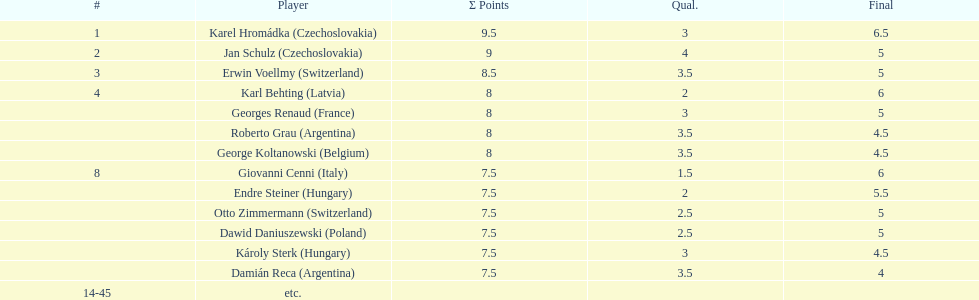How many participants scored 8 points? 4. 